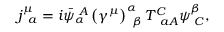Convert formula to latex. <formula><loc_0><loc_0><loc_500><loc_500>j _ { \, a } ^ { \mu } = i \bar { \psi } _ { \alpha } ^ { \, A } \left ( \gamma ^ { \mu } \right ) _ { \, \beta } ^ { \alpha } T _ { \, a A } ^ { C } \psi _ { \, C } ^ { \beta } ,</formula> 